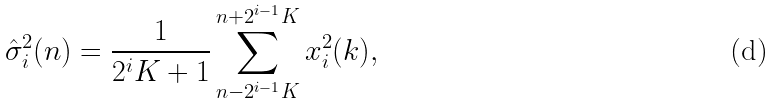Convert formula to latex. <formula><loc_0><loc_0><loc_500><loc_500>\hat { \sigma } _ { i } ^ { 2 } ( n ) = \frac { 1 } { 2 ^ { i } K + 1 } \sum _ { n - 2 ^ { i - 1 } K } ^ { n + 2 ^ { i - 1 } K } x _ { i } ^ { 2 } ( k ) ,</formula> 